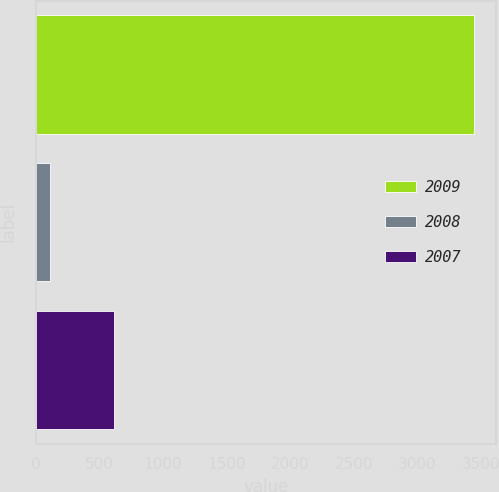Convert chart to OTSL. <chart><loc_0><loc_0><loc_500><loc_500><bar_chart><fcel>2009<fcel>2008<fcel>2007<nl><fcel>3449<fcel>112<fcel>612<nl></chart> 